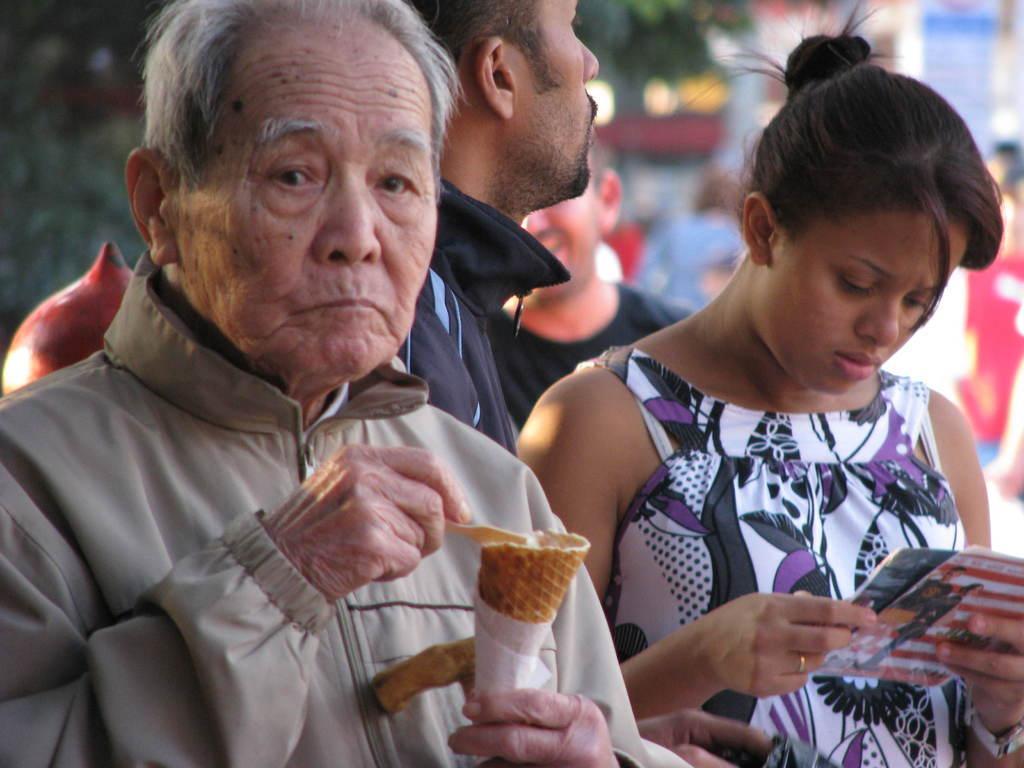How would you summarize this image in a sentence or two? In this picture we can see people. We can see an old man holding an ice-cream with a tissue paper and a spoon. Beside to him we can see a woman, she is holding a book and staring. Background portion of the picture is blur. 